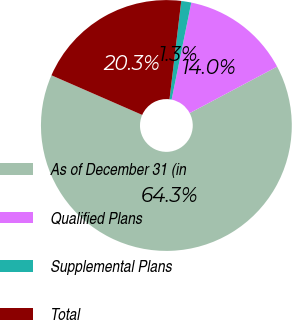Convert chart to OTSL. <chart><loc_0><loc_0><loc_500><loc_500><pie_chart><fcel>As of December 31 (in<fcel>Qualified Plans<fcel>Supplemental Plans<fcel>Total<nl><fcel>64.32%<fcel>14.04%<fcel>1.29%<fcel>20.34%<nl></chart> 